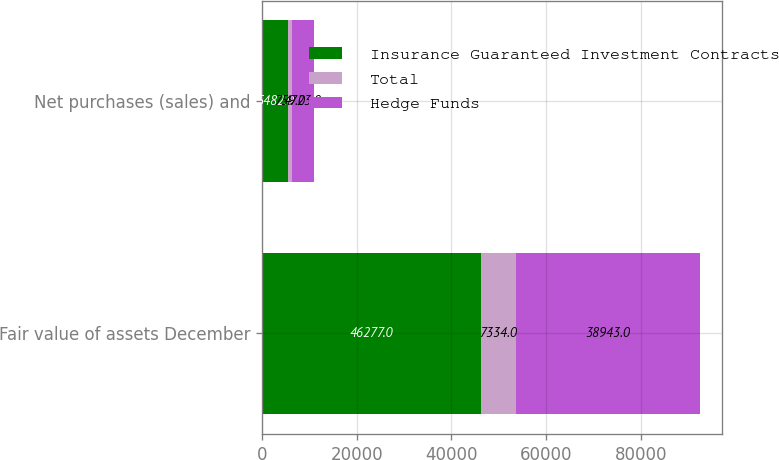Convert chart. <chart><loc_0><loc_0><loc_500><loc_500><stacked_bar_chart><ecel><fcel>Fair value of assets December<fcel>Net purchases (sales) and<nl><fcel>Insurance Guaranteed Investment Contracts<fcel>46277<fcel>5482<nl><fcel>Total<fcel>7334<fcel>759<nl><fcel>Hedge Funds<fcel>38943<fcel>4723<nl></chart> 